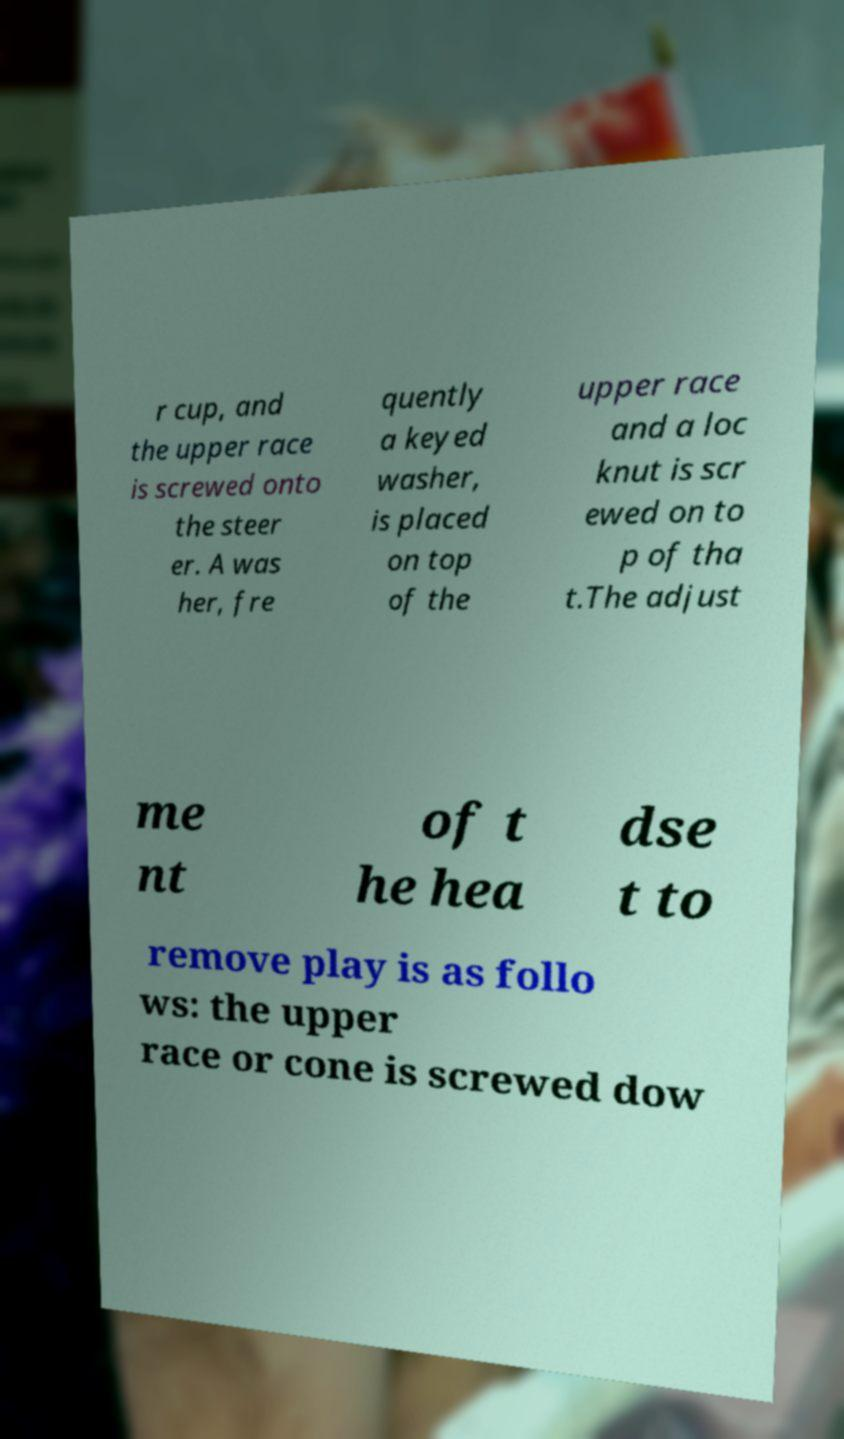Could you extract and type out the text from this image? r cup, and the upper race is screwed onto the steer er. A was her, fre quently a keyed washer, is placed on top of the upper race and a loc knut is scr ewed on to p of tha t.The adjust me nt of t he hea dse t to remove play is as follo ws: the upper race or cone is screwed dow 